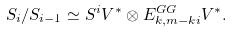<formula> <loc_0><loc_0><loc_500><loc_500>S _ { i } / S _ { i - 1 } \simeq S ^ { i } V ^ { \ast } \otimes E _ { k , m - k i } ^ { G G } V ^ { \ast } .</formula> 